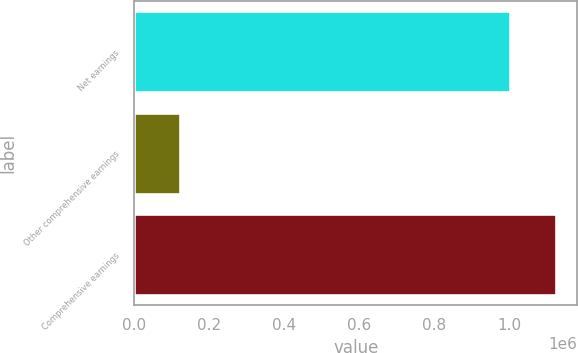Convert chart. <chart><loc_0><loc_0><loc_500><loc_500><bar_chart><fcel>Net earnings<fcel>Other comprehensive earnings<fcel>Comprehensive earnings<nl><fcel>1.00313e+06<fcel>122629<fcel>1.12576e+06<nl></chart> 